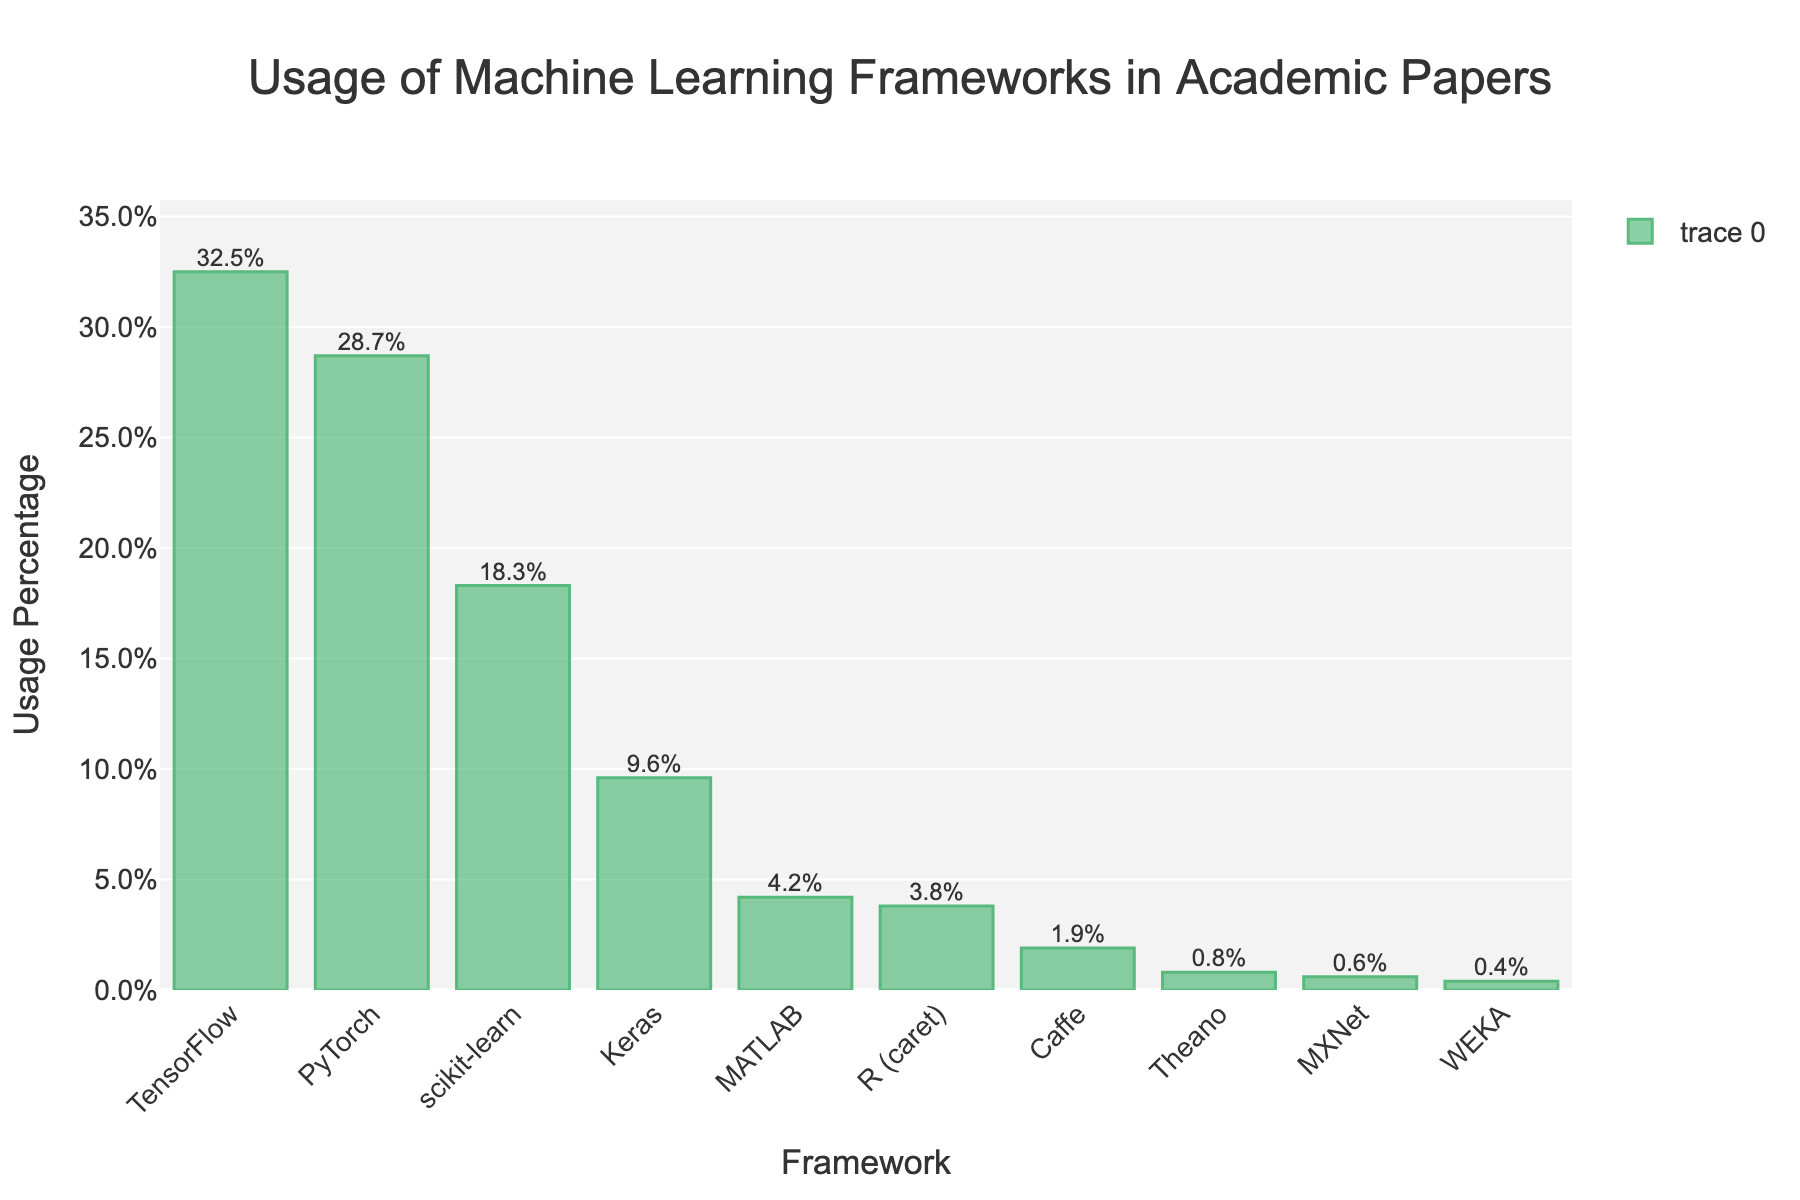Which framework has the highest usage percentage? The framework with the highest bar indicates the highest usage percentage. TensorFlow has the highest bar.
Answer: TensorFlow Which frameworks have usage percentages greater than 25%? Look at the bars and identify frameworks with bars extending above the 25% mark. TensorFlow and PyTorch have bars above 25%.
Answer: TensorFlow, PyTorch What is the combined usage percentage of the least popular three frameworks? Identify the three frameworks with the smallest bars (Theano, MXNet, WEKA), then sum their percentages: 0.8% + 0.6% + 0.4% = 1.8%.
Answer: 1.8% How much more popular is Keras compared to MATLAB? Find the difference in their percentages: Keras (9.6%) - MATLAB (4.2%) = 5.4%.
Answer: 5.4% Which framework has a usage percentage of exactly 0.8%? Look for the bar with the label nearest to 0.8%.
Answer: Theano What is the average usage percentage of the top 5 frameworks? Identify the top 5 bars (TensorFlow, PyTorch, scikit-learn, Keras, and MATLAB) and calculate their average: (32.5 + 28.7 + 18.3 + 9.6 + 4.2) / 5 = 18.66%.
Answer: 18.66% What's the usage range (difference between the highest and lowest percentage) of the frameworks? Subtract the smallest percentage (WEKA, 0.4%) from the largest percentage (TensorFlow, 32.5%): 32.5% - 0.4% = 32.1%.
Answer: 32.1% By which percentage is PyTorch less popular than TensorFlow? Subtract PyTorch's percentage from TensorFlow's: 32.5% - 28.7% = 3.8%.
Answer: 3.8% How many frameworks have a usage percentage below 5%? Count the bars where the usage percentage is less than 5%. There are 5 such frameworks (MATLAB, R (caret), Caffe, Theano, MXNet, WEKA).
Answer: 6 What is the sum of usage percentages for frameworks other than the top 3? Exclude TensorFlow, PyTorch, and scikit-learn, then sum the others: 9.6 + 4.2 + 3.8 + 1.9 + 0.8 + 0.6 + 0.4 = 21.3%.
Answer: 21.3% 